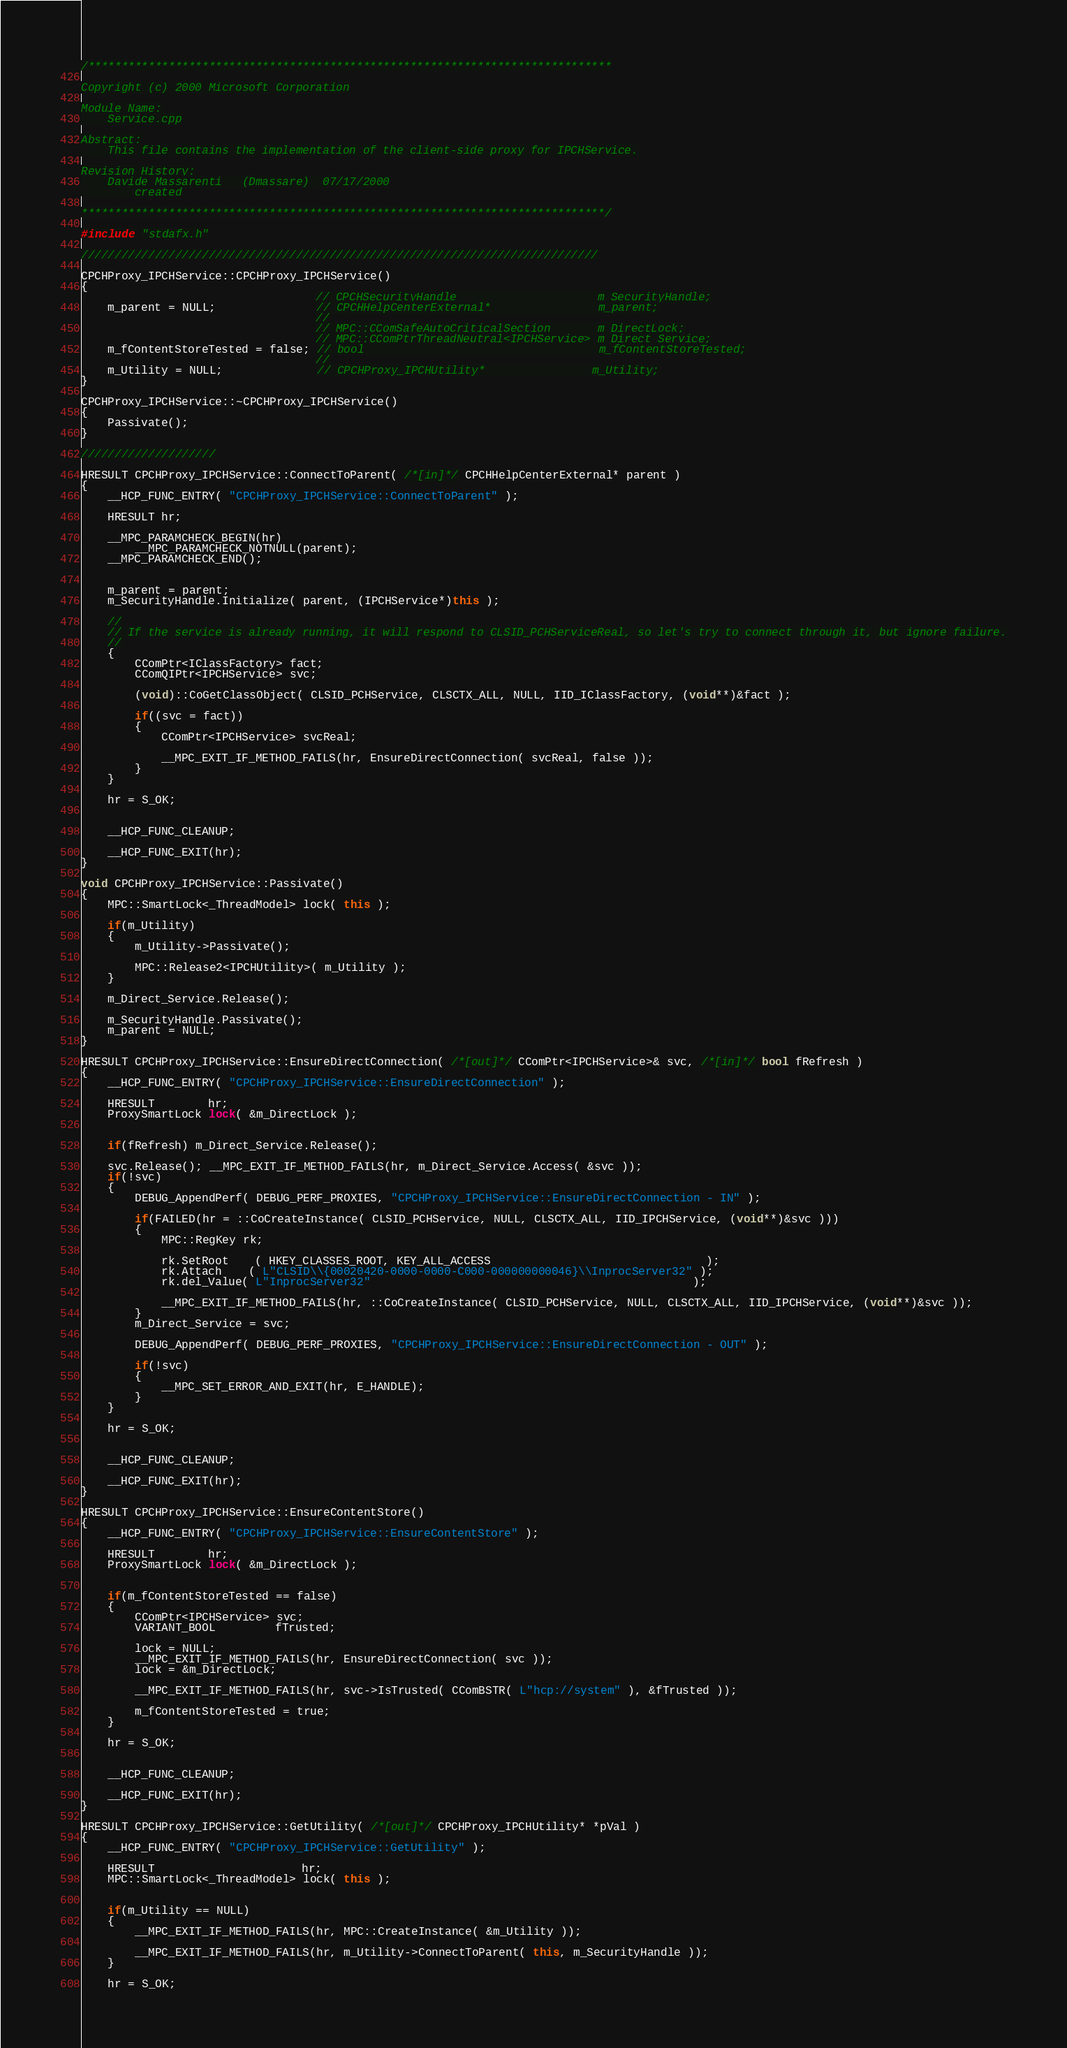<code> <loc_0><loc_0><loc_500><loc_500><_C++_>/******************************************************************************

Copyright (c) 2000 Microsoft Corporation

Module Name:
    Service.cpp

Abstract:
    This file contains the implementation of the client-side proxy for IPCHService.

Revision History:
    Davide Massarenti   (Dmassare)  07/17/2000
        created

******************************************************************************/

#include "stdafx.h"

/////////////////////////////////////////////////////////////////////////////

CPCHProxy_IPCHService::CPCHProxy_IPCHService()
{
					 			   // CPCHSecurityHandle                     m_SecurityHandle;
    m_parent = NULL; 			   // CPCHHelpCenterExternal*                m_parent;
					 			   //
					 			   // MPC::CComSafeAutoCriticalSection       m_DirectLock;
					 			   // MPC::CComPtrThreadNeutral<IPCHService> m_Direct_Service;
	m_fContentStoreTested = false; // bool                                   m_fContentStoreTested;
					 			   //
	m_Utility = NULL;              // CPCHProxy_IPCHUtility* 		         m_Utility;
}

CPCHProxy_IPCHService::~CPCHProxy_IPCHService()
{
    Passivate();
}

////////////////////

HRESULT CPCHProxy_IPCHService::ConnectToParent( /*[in]*/ CPCHHelpCenterExternal* parent )
{
    __HCP_FUNC_ENTRY( "CPCHProxy_IPCHService::ConnectToParent" );

    HRESULT hr;

    __MPC_PARAMCHECK_BEGIN(hr)
        __MPC_PARAMCHECK_NOTNULL(parent);
    __MPC_PARAMCHECK_END();


    m_parent = parent;
    m_SecurityHandle.Initialize( parent, (IPCHService*)this );

	//
	// If the service is already running, it will respond to CLSID_PCHServiceReal, so let's try to connect through it, but ignore failure.
	//
	{
		CComPtr<IClassFactory> fact;
		CComQIPtr<IPCHService> svc;

		(void)::CoGetClassObject( CLSID_PCHService, CLSCTX_ALL, NULL, IID_IClassFactory, (void**)&fact );

		if((svc = fact))
		{
			CComPtr<IPCHService> svcReal;

			__MPC_EXIT_IF_METHOD_FAILS(hr, EnsureDirectConnection( svcReal, false ));
		}
	}

    hr = S_OK;


    __HCP_FUNC_CLEANUP;

    __HCP_FUNC_EXIT(hr);
}

void CPCHProxy_IPCHService::Passivate()
{
    MPC::SmartLock<_ThreadModel> lock( this );

	if(m_Utility)
	{
        m_Utility->Passivate();

		MPC::Release2<IPCHUtility>( m_Utility );
	}

    m_Direct_Service.Release();

    m_SecurityHandle.Passivate();
    m_parent = NULL;
}

HRESULT CPCHProxy_IPCHService::EnsureDirectConnection( /*[out]*/ CComPtr<IPCHService>& svc, /*[in]*/ bool fRefresh )
{
    __HCP_FUNC_ENTRY( "CPCHProxy_IPCHService::EnsureDirectConnection" );

    HRESULT        hr;
    ProxySmartLock lock( &m_DirectLock );


	if(fRefresh) m_Direct_Service.Release();

	svc.Release(); __MPC_EXIT_IF_METHOD_FAILS(hr, m_Direct_Service.Access( &svc ));
    if(!svc)
    {
		DEBUG_AppendPerf( DEBUG_PERF_PROXIES, "CPCHProxy_IPCHService::EnsureDirectConnection - IN" );

        if(FAILED(hr = ::CoCreateInstance( CLSID_PCHService, NULL, CLSCTX_ALL, IID_IPCHService, (void**)&svc )))
		{
			MPC::RegKey rk;

			rk.SetRoot	( HKEY_CLASSES_ROOT, KEY_ALL_ACCESS                                );
			rk.Attach 	( L"CLSID\\{00020420-0000-0000-C000-000000000046}\\InprocServer32" );
			rk.del_Value( L"InprocServer32"                                                );

			__MPC_EXIT_IF_METHOD_FAILS(hr, ::CoCreateInstance( CLSID_PCHService, NULL, CLSCTX_ALL, IID_IPCHService, (void**)&svc ));
		}
		m_Direct_Service = svc;

		DEBUG_AppendPerf( DEBUG_PERF_PROXIES, "CPCHProxy_IPCHService::EnsureDirectConnection - OUT" );

		if(!svc)
		{
			__MPC_SET_ERROR_AND_EXIT(hr, E_HANDLE);
		}
	}

    hr = S_OK;


    __HCP_FUNC_CLEANUP;

    __HCP_FUNC_EXIT(hr);
}

HRESULT CPCHProxy_IPCHService::EnsureContentStore()
{
    __HCP_FUNC_ENTRY( "CPCHProxy_IPCHService::EnsureContentStore" );

    HRESULT        hr;
    ProxySmartLock lock( &m_DirectLock );


	if(m_fContentStoreTested == false)
	{
		CComPtr<IPCHService> svc;
		VARIANT_BOOL         fTrusted;

		lock = NULL;
		__MPC_EXIT_IF_METHOD_FAILS(hr, EnsureDirectConnection( svc ));
		lock = &m_DirectLock;

		__MPC_EXIT_IF_METHOD_FAILS(hr, svc->IsTrusted( CComBSTR( L"hcp://system" ), &fTrusted ));

		m_fContentStoreTested = true;
	}

    hr = S_OK;


    __HCP_FUNC_CLEANUP;

    __HCP_FUNC_EXIT(hr);
}

HRESULT CPCHProxy_IPCHService::GetUtility( /*[out]*/ CPCHProxy_IPCHUtility* *pVal )
{
    __HCP_FUNC_ENTRY( "CPCHProxy_IPCHService::GetUtility" );

    HRESULT                      hr;
    MPC::SmartLock<_ThreadModel> lock( this );


    if(m_Utility == NULL)
    {
        __MPC_EXIT_IF_METHOD_FAILS(hr, MPC::CreateInstance( &m_Utility ));

		__MPC_EXIT_IF_METHOD_FAILS(hr, m_Utility->ConnectToParent( this, m_SecurityHandle ));
	}

    hr = S_OK;

</code> 